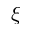<formula> <loc_0><loc_0><loc_500><loc_500>\xi</formula> 